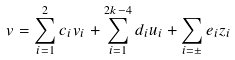Convert formula to latex. <formula><loc_0><loc_0><loc_500><loc_500>v = \sum _ { i = 1 } ^ { 2 } c _ { i } v _ { i } + \sum _ { i = 1 } ^ { 2 k - 4 } d _ { i } u _ { i } + \sum _ { i = \pm } e _ { i } z _ { i }</formula> 